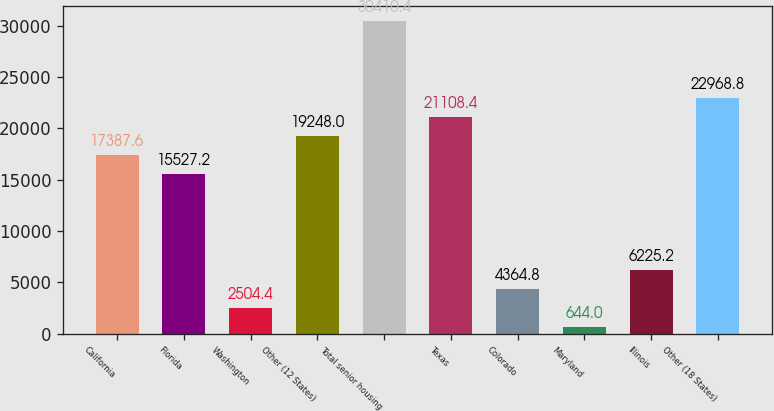<chart> <loc_0><loc_0><loc_500><loc_500><bar_chart><fcel>California<fcel>Florida<fcel>Washington<fcel>Other (12 States)<fcel>Total senior housing<fcel>Texas<fcel>Colorado<fcel>Maryland<fcel>Illinois<fcel>Other (18 States)<nl><fcel>17387.6<fcel>15527.2<fcel>2504.4<fcel>19248<fcel>30410.4<fcel>21108.4<fcel>4364.8<fcel>644<fcel>6225.2<fcel>22968.8<nl></chart> 